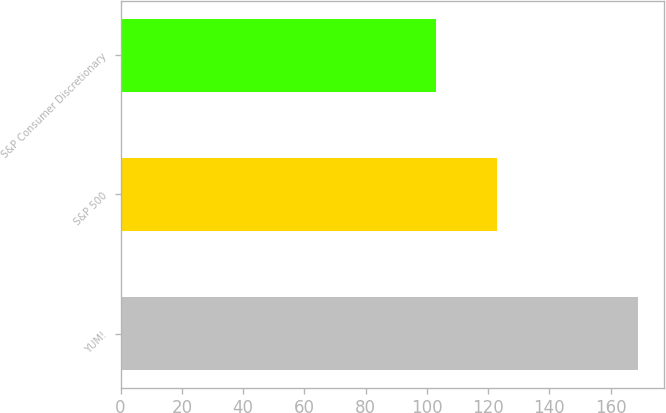Convert chart to OTSL. <chart><loc_0><loc_0><loc_500><loc_500><bar_chart><fcel>YUM!<fcel>S&P 500<fcel>S&P Consumer Discretionary<nl><fcel>169<fcel>123<fcel>103<nl></chart> 